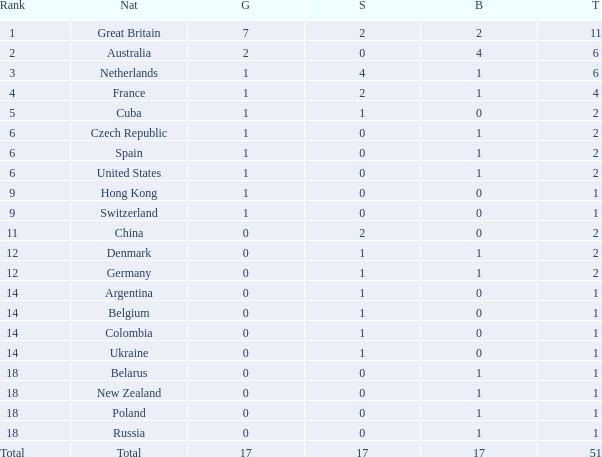Tell me the lowest gold for rank of 6 and total less than 2 None. 